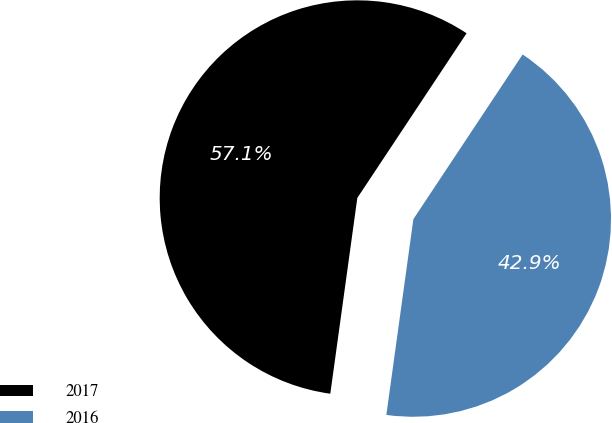<chart> <loc_0><loc_0><loc_500><loc_500><pie_chart><fcel>2017<fcel>2016<nl><fcel>57.14%<fcel>42.86%<nl></chart> 